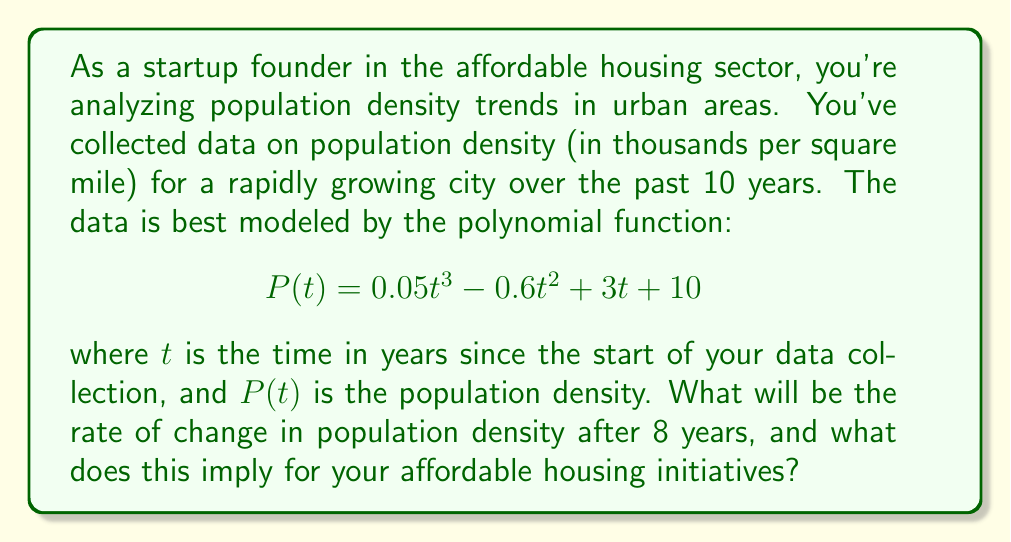Could you help me with this problem? To solve this problem, we need to follow these steps:

1) The rate of change in population density is given by the first derivative of the function $P(t)$. Let's call this $P'(t)$.

2) To find $P'(t)$, we differentiate $P(t)$ with respect to $t$:

   $$P'(t) = \frac{d}{dt}(0.05t^3 - 0.6t^2 + 3t + 10)$$

3) Using the power rule of differentiation:

   $$P'(t) = 0.15t^2 - 1.2t + 3$$

4) We want to find the rate of change after 8 years, so we evaluate $P'(8)$:

   $$P'(8) = 0.15(8)^2 - 1.2(8) + 3$$
   $$= 0.15(64) - 9.6 + 3$$
   $$= 9.6 - 9.6 + 3 = 3$$

5) Therefore, after 8 years, the rate of change in population density will be 3 thousand per square mile per year.

6) This positive rate of change implies that the population density is still increasing after 8 years. For affordable housing initiatives, this suggests a growing demand for housing, particularly in dense urban areas. It indicates a need for continued focus on developing and maintaining affordable housing options to accommodate the increasing population density.
Answer: 3 thousand per square mile per year; implies increasing housing demand 